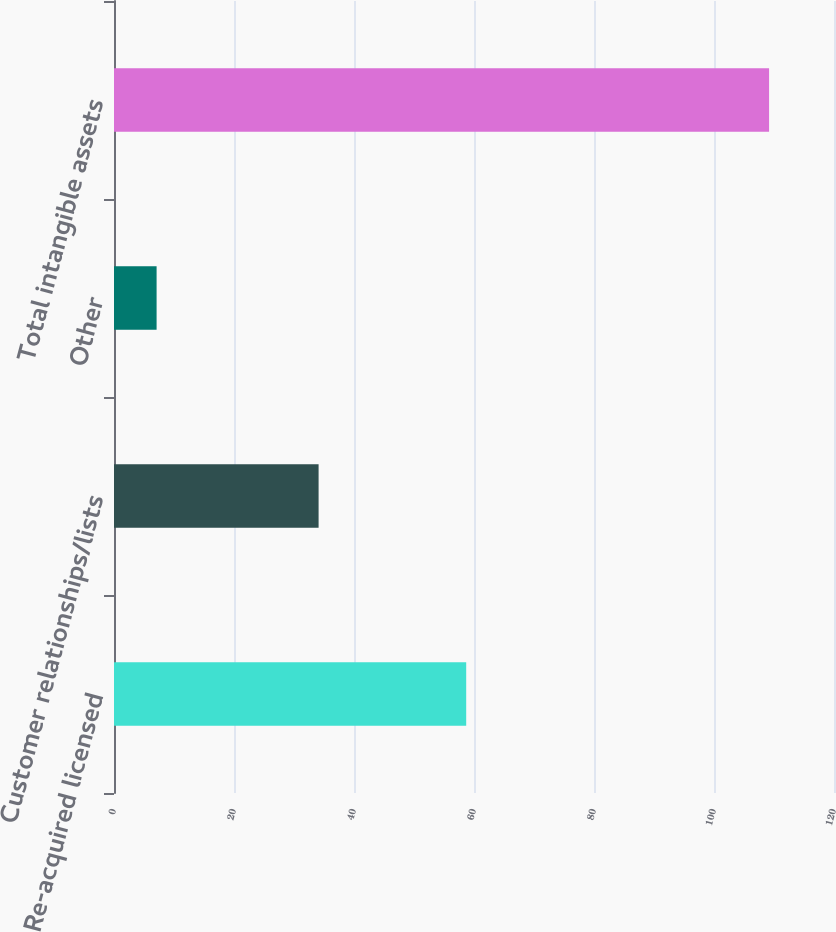<chart> <loc_0><loc_0><loc_500><loc_500><bar_chart><fcel>Re-acquired licensed<fcel>Customer relationships/lists<fcel>Other<fcel>Total intangible assets<nl><fcel>58.7<fcel>34.1<fcel>7.1<fcel>109.18<nl></chart> 